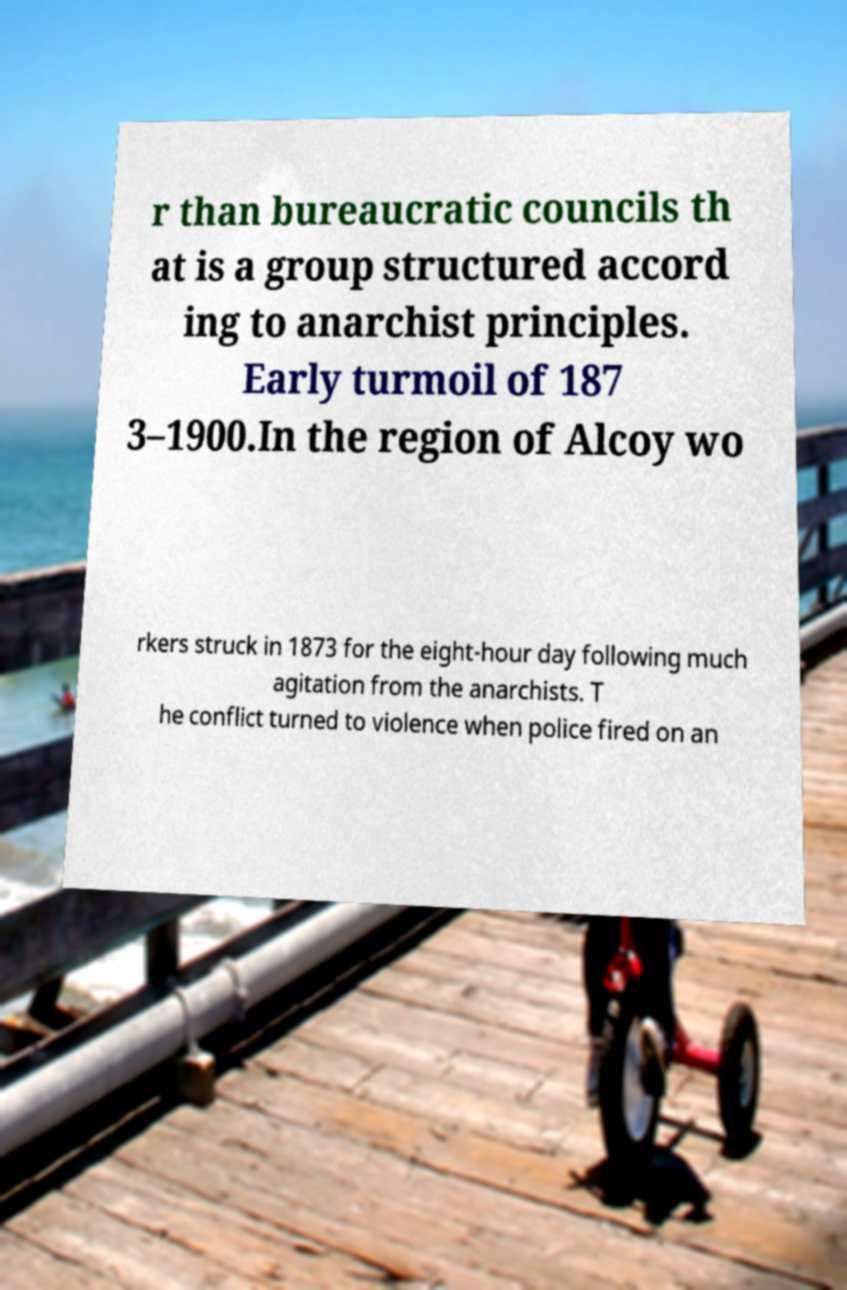Can you read and provide the text displayed in the image?This photo seems to have some interesting text. Can you extract and type it out for me? r than bureaucratic councils th at is a group structured accord ing to anarchist principles. Early turmoil of 187 3–1900.In the region of Alcoy wo rkers struck in 1873 for the eight-hour day following much agitation from the anarchists. T he conflict turned to violence when police fired on an 